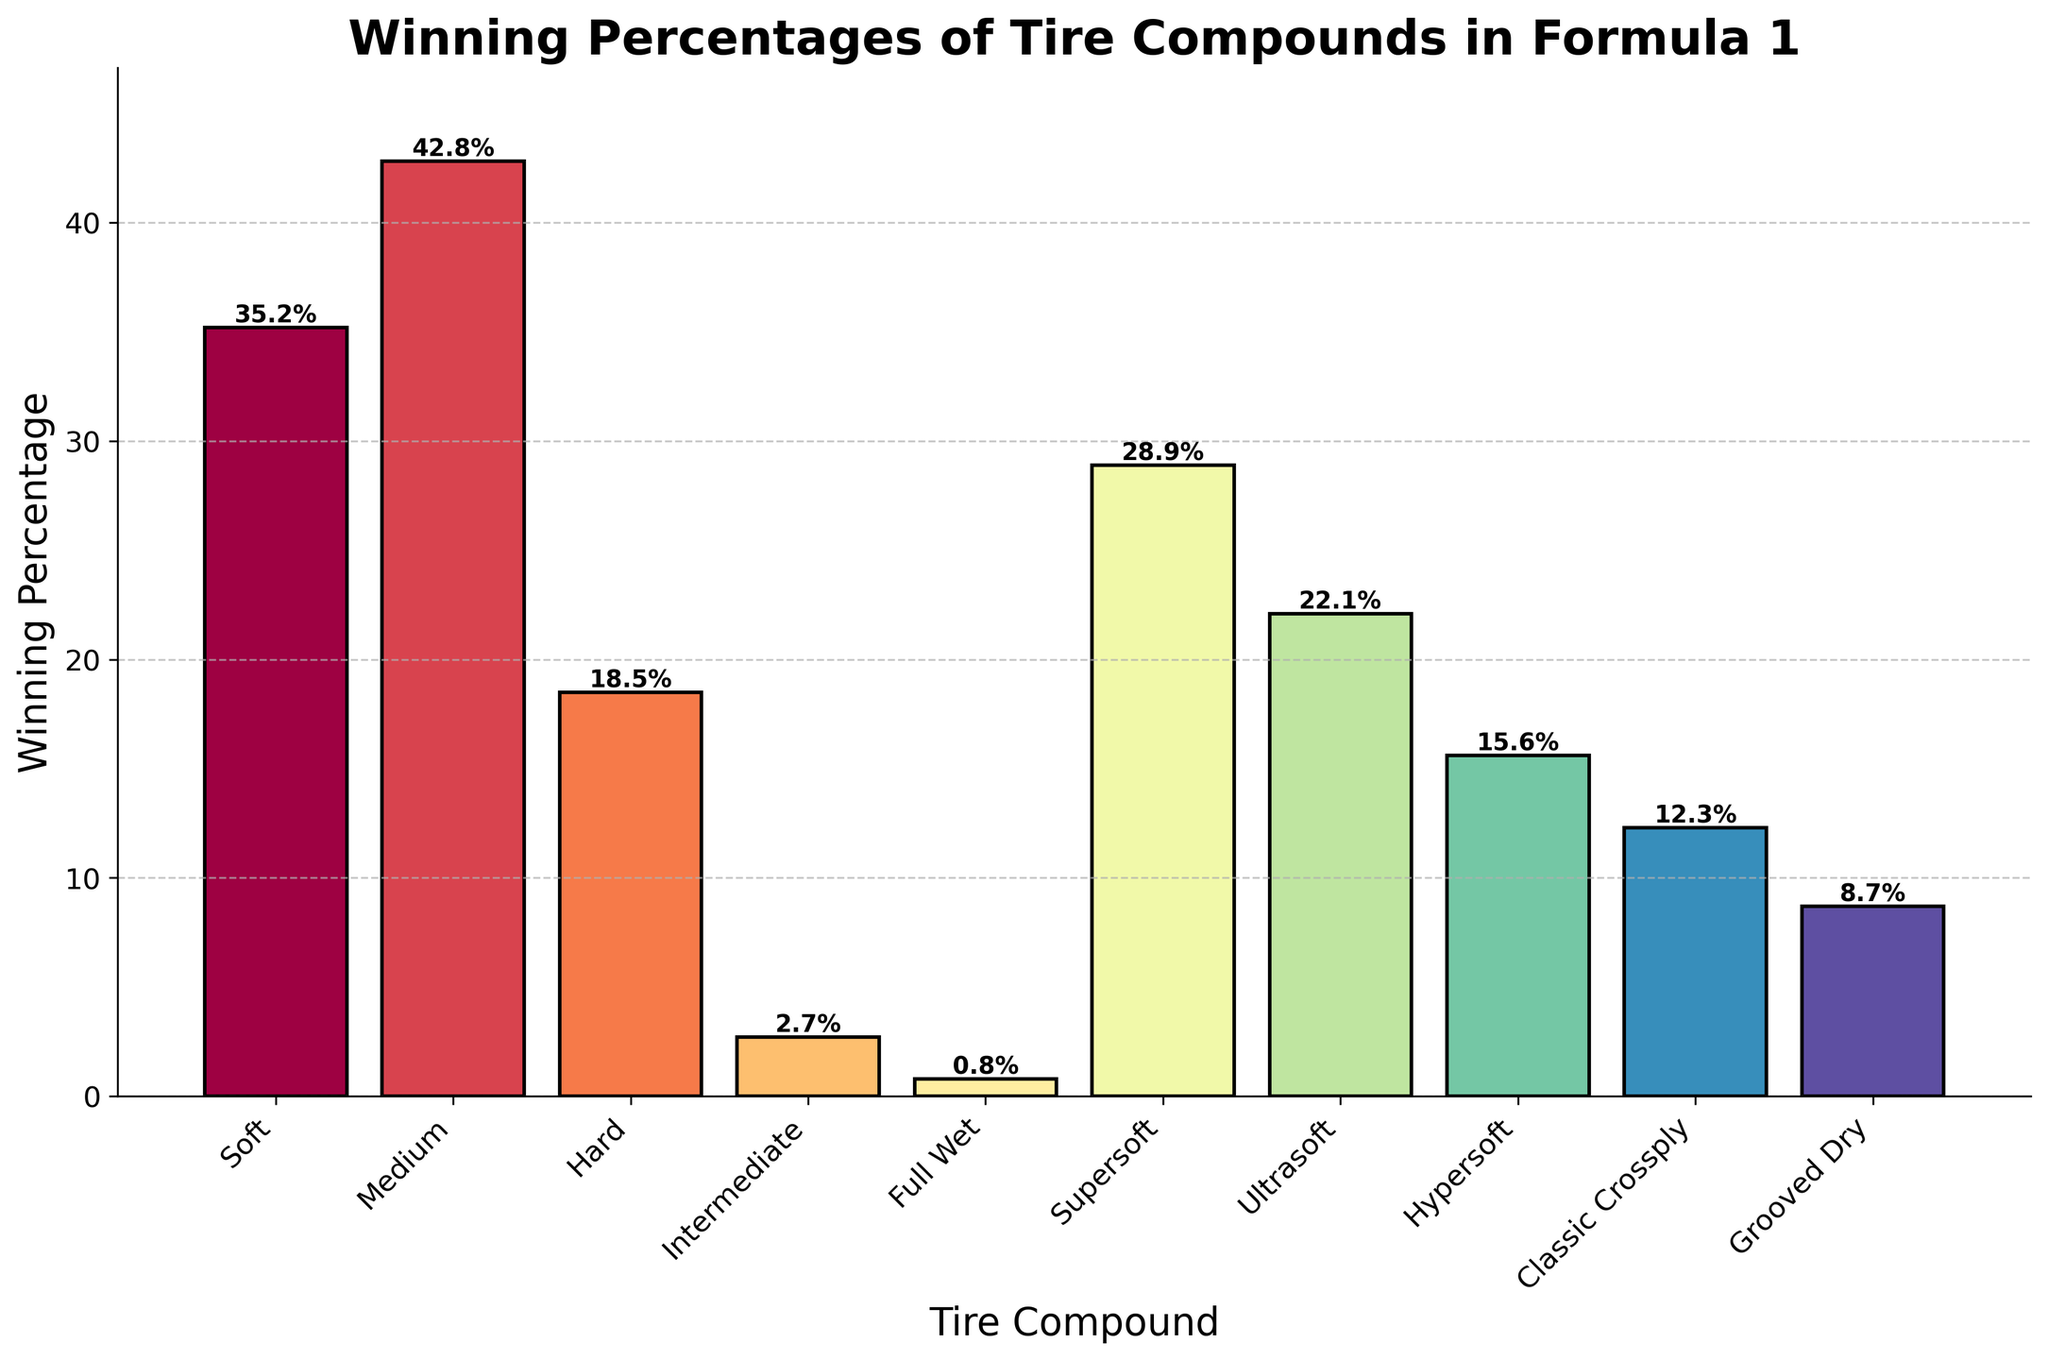Which tire compound has the highest winning percentage? The bar representing 'Medium' tire compound is the tallest in the chart. The height of the bar is 42.8%.
Answer: Medium Which tire compounds have winning percentages greater than 20%? The tire compounds with bars passing the 20% mark are 'Soft,' 'Medium,' 'Supersoft,' and 'Ultrasoft,' based on their heights.
Answer: Soft, Medium, Supersoft, Ultrasoft How much more winning percentage does the 'Soft' compound have compared to the 'Classic Crossply'? 'Soft' has a winning percentage of 35.2%, and 'Classic Crossply' has 12.3%. Subtracting 12.3 from 35.2, we get 22.9%.
Answer: 22.9% Is the winning percentage of the 'Full Wet' tire compound less than 1%? The height of the 'Full Wet' tire compound bar is 0.8%, as indicated in the bar's label. It is indeed less than 1%.
Answer: Yes What is the difference in winning percentage between the 'Hard' and 'Hypersoft' tire compounds? 'Hard' has a winning percentage of 18.5%, and 'Hypersoft' has 15.6%. The difference is 18.5 - 15.6 = 2.9%.
Answer: 2.9% Do 'Grooved Dry' tires have a higher winning percentage than 'Classic Crossply' tires? The bar for 'Grooved Dry' (8.7%) is shorter than the bar for 'Classic Crossply' (12.3%). Therefore, 'Grooved Dry' has a lower winning percentage.
Answer: No What is the combined winning percentage of 'Soft,' 'Medium,' and 'Supersoft' tire compounds? Adding 35.2% (Soft), 42.8% (Medium), and 28.9% (Supersoft) gives a combined percentage of 106.9%.
Answer: 106.9% Which tire compound has the second lowest winning percentage? The bar for 'Intermediate' tires (2.7%) is the second shortest, with 'Full Wet' tires (0.8%) having the lowest.
Answer: Intermediate Are there any tire compounds with winning percentages between 10% and 20%? The tire compounds within this range (based on bar heights) are 'Hard' (18.5%), 'Hypersoft' (15.6%), 'Classic Crossply' (12.3%), and 'Grooved Dry' (8.7%).
Answer: Yes (Hard, Hypersoft, Classic Crossply) Which tire compound's bar is closest in height to the 'Ultrasoft' tire compound bar? The 'Hypersoft' bar at 15.6% is closest in height to the 'Ultrasoft' bar at 22.1%. The difference is 22.1 - 15.6 = 6.5%.
Answer: Hypersoft 